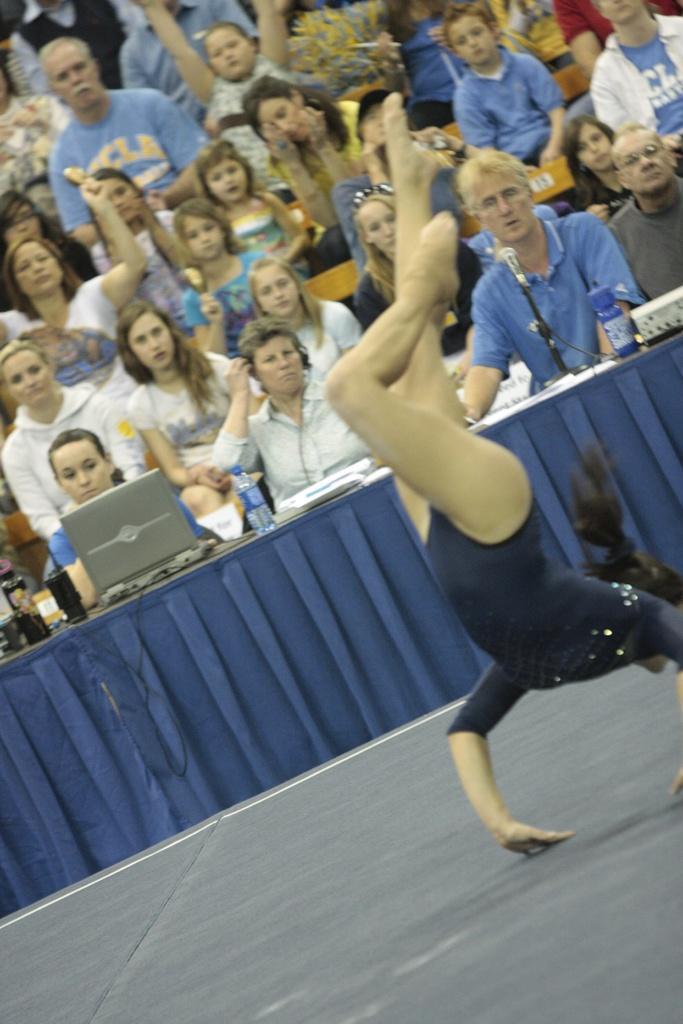Please provide a concise description of this image. In the center of the image we can see a person performing on the floor. In the background we can see table, laptop, bottle, mic and a group of persons. 